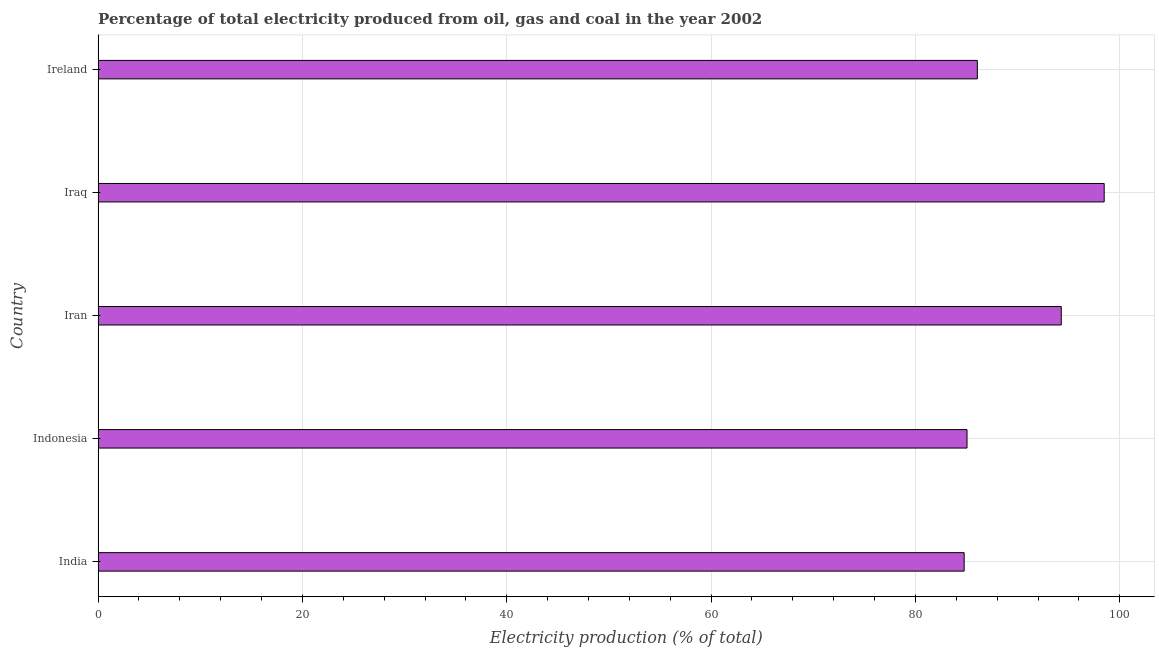Does the graph contain grids?
Provide a succinct answer. Yes. What is the title of the graph?
Offer a very short reply. Percentage of total electricity produced from oil, gas and coal in the year 2002. What is the label or title of the X-axis?
Offer a terse response. Electricity production (% of total). What is the label or title of the Y-axis?
Offer a terse response. Country. What is the electricity production in Indonesia?
Offer a terse response. 85.05. Across all countries, what is the maximum electricity production?
Make the answer very short. 98.47. Across all countries, what is the minimum electricity production?
Make the answer very short. 84.77. In which country was the electricity production maximum?
Offer a very short reply. Iraq. What is the sum of the electricity production?
Your response must be concise. 448.62. What is the difference between the electricity production in India and Indonesia?
Your answer should be compact. -0.28. What is the average electricity production per country?
Offer a terse response. 89.72. What is the median electricity production?
Ensure brevity in your answer.  86.06. What is the ratio of the electricity production in Indonesia to that in Iraq?
Give a very brief answer. 0.86. What is the difference between the highest and the second highest electricity production?
Your answer should be very brief. 4.2. How many countries are there in the graph?
Offer a terse response. 5. What is the difference between two consecutive major ticks on the X-axis?
Provide a short and direct response. 20. Are the values on the major ticks of X-axis written in scientific E-notation?
Provide a short and direct response. No. What is the Electricity production (% of total) of India?
Your answer should be compact. 84.77. What is the Electricity production (% of total) of Indonesia?
Your response must be concise. 85.05. What is the Electricity production (% of total) in Iran?
Give a very brief answer. 94.27. What is the Electricity production (% of total) of Iraq?
Provide a short and direct response. 98.47. What is the Electricity production (% of total) in Ireland?
Keep it short and to the point. 86.06. What is the difference between the Electricity production (% of total) in India and Indonesia?
Ensure brevity in your answer.  -0.28. What is the difference between the Electricity production (% of total) in India and Iran?
Offer a very short reply. -9.5. What is the difference between the Electricity production (% of total) in India and Iraq?
Your response must be concise. -13.7. What is the difference between the Electricity production (% of total) in India and Ireland?
Provide a succinct answer. -1.29. What is the difference between the Electricity production (% of total) in Indonesia and Iran?
Offer a terse response. -9.22. What is the difference between the Electricity production (% of total) in Indonesia and Iraq?
Offer a very short reply. -13.43. What is the difference between the Electricity production (% of total) in Indonesia and Ireland?
Provide a succinct answer. -1.01. What is the difference between the Electricity production (% of total) in Iran and Iraq?
Ensure brevity in your answer.  -4.2. What is the difference between the Electricity production (% of total) in Iran and Ireland?
Make the answer very short. 8.21. What is the difference between the Electricity production (% of total) in Iraq and Ireland?
Your answer should be very brief. 12.42. What is the ratio of the Electricity production (% of total) in India to that in Iran?
Keep it short and to the point. 0.9. What is the ratio of the Electricity production (% of total) in India to that in Iraq?
Make the answer very short. 0.86. What is the ratio of the Electricity production (% of total) in Indonesia to that in Iran?
Your answer should be compact. 0.9. What is the ratio of the Electricity production (% of total) in Indonesia to that in Iraq?
Your answer should be compact. 0.86. What is the ratio of the Electricity production (% of total) in Iran to that in Iraq?
Your answer should be compact. 0.96. What is the ratio of the Electricity production (% of total) in Iran to that in Ireland?
Give a very brief answer. 1.09. What is the ratio of the Electricity production (% of total) in Iraq to that in Ireland?
Give a very brief answer. 1.14. 